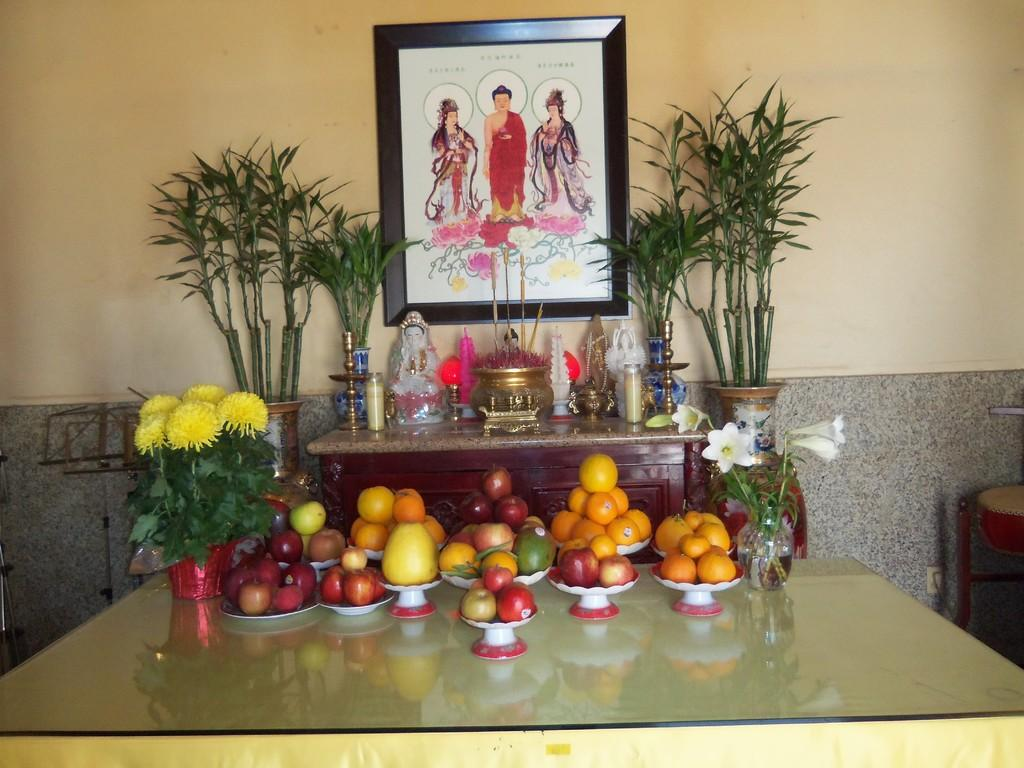What is the main piece of furniture in the image? There is a table in the image. What is placed on the table? There are fruits and a flower vase on the table. What can be seen in the background of the image? There is a wall, a frame, and plants in the background of the image. What type of agreement is being signed in the image? There is no indication of an agreement or signing in the image; it features a table with fruits and a flower vase, along with a background containing a wall, frame, and plants. 